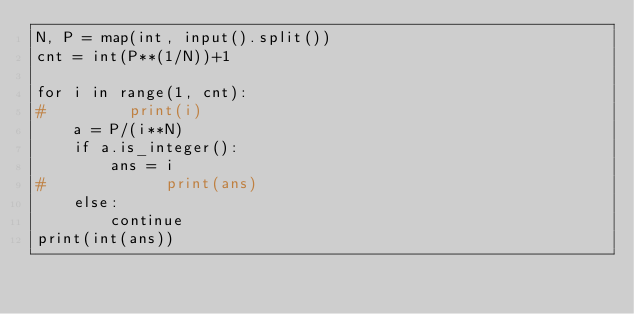<code> <loc_0><loc_0><loc_500><loc_500><_Python_>N, P = map(int, input().split())
cnt = int(P**(1/N))+1

for i in range(1, cnt):
#         print(i)
    a = P/(i**N)
    if a.is_integer():
        ans = i
#             print(ans)
    else:
        continue
print(int(ans))</code> 